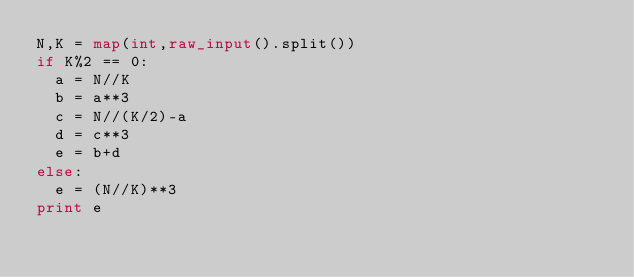<code> <loc_0><loc_0><loc_500><loc_500><_Python_>N,K = map(int,raw_input().split())
if K%2 == 0:
  a = N//K
  b = a**3
  c = N//(K/2)-a
  d = c**3
  e = b+d
else:
  e = (N//K)**3
print e</code> 